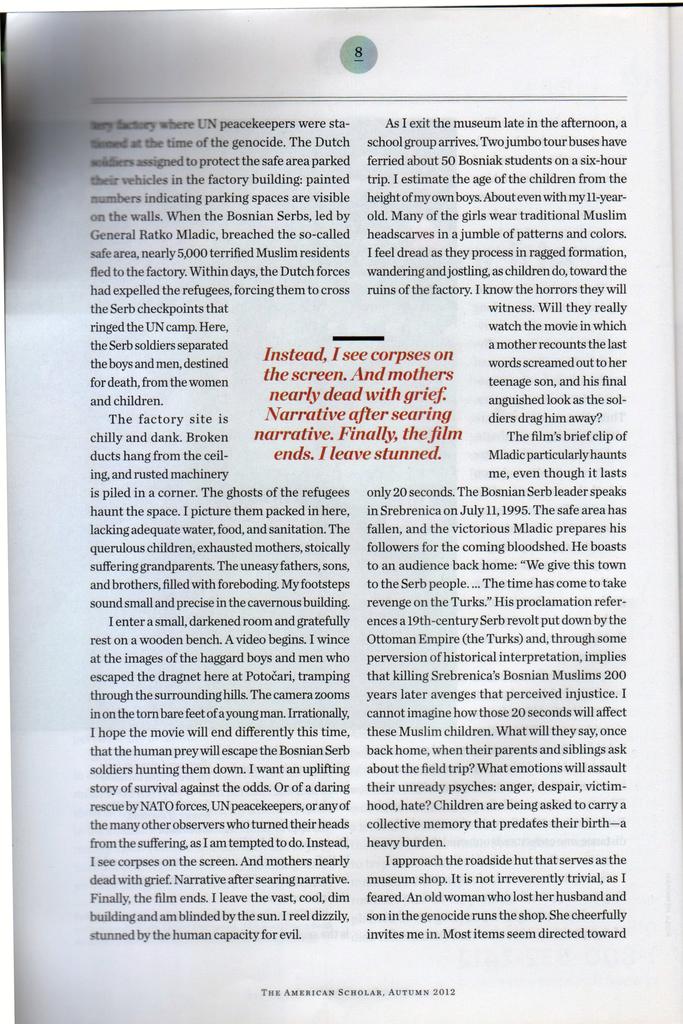What do i see on the screen?
Your answer should be compact. Answering does not require reading text in the image. What page number is featured here?
Ensure brevity in your answer.  8. 